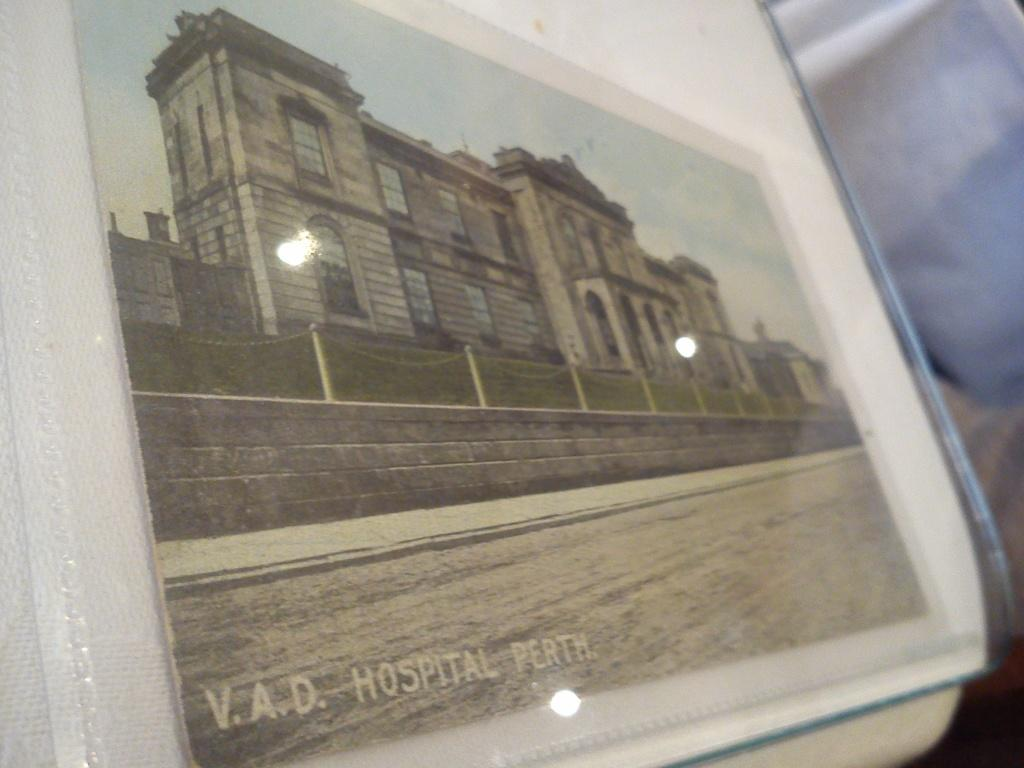What is depicted on the poster in the image? There is a poster of a hospital in the image. Can you see any lakes or bodies of water in the image? No, there are no lakes or bodies of water visible in the image. Are there any balls or spherical objects present in the image? No, there are no balls or spherical objects present in the image. 